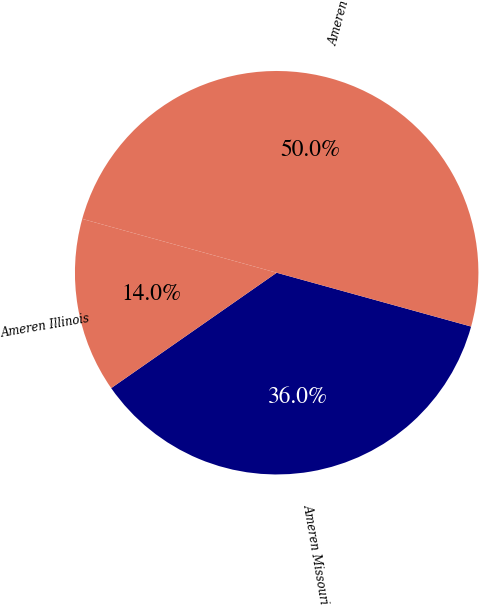Convert chart to OTSL. <chart><loc_0><loc_0><loc_500><loc_500><pie_chart><fcel>Ameren Missouri<fcel>Ameren Illinois<fcel>Ameren<nl><fcel>36.01%<fcel>13.99%<fcel>50.0%<nl></chart> 